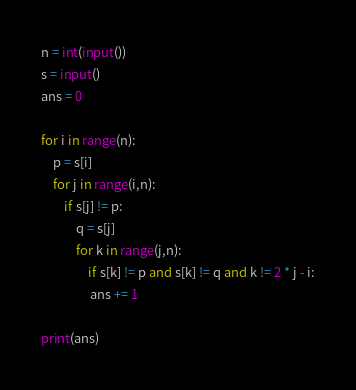<code> <loc_0><loc_0><loc_500><loc_500><_Python_>n = int(input())
s = input()
ans = 0

for i in range(n):
    p = s[i]
    for j in range(i,n):
        if s[j] != p:
            q = s[j]
            for k in range(j,n):
                if s[k] != p and s[k] != q and k != 2 * j - i:
                 ans += 1

print(ans)</code> 